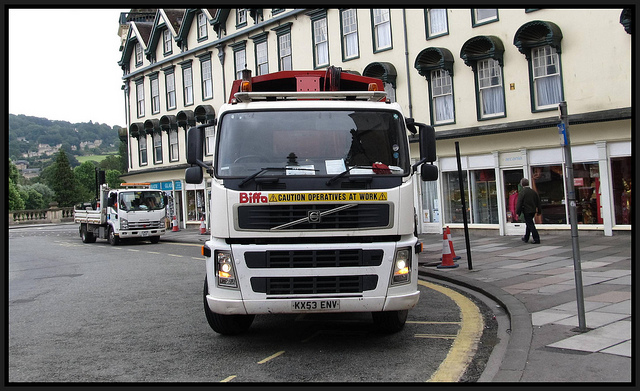Please extract the text content from this image. BIFFA CAUTION OPERATIVES AT WORK ENV KX53 